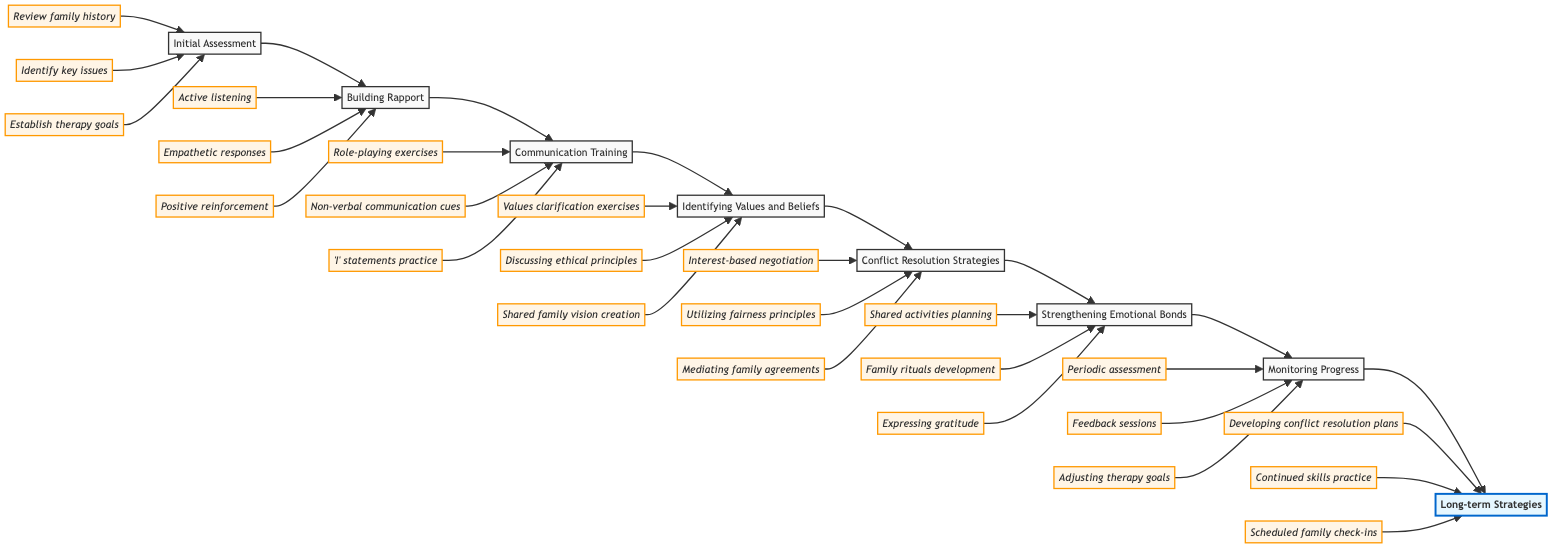What is the first step in the family therapy process? The first step in the family therapy process is depicted as the node labeled "Initial Assessment." This is the starting point of the flowchart.
Answer: Initial Assessment How many steps are included in the flowchart? By counting the nodes in the diagram, there are eight distinct steps involved in the family therapy process.
Answer: 8 What action is associated with "Building Rapport"? The actions related to "Building Rapport" include "Active listening," "Empathetic responses," and "Positive reinforcement," as indicated below this step in the diagram.
Answer: Active listening, Empathetic responses, Positive reinforcement Which step follows “Communication Training”? The flowchart shows that the step that immediately follows "Communication Training" is "Identifying Values and Beliefs." This is directly connected to "Communication Training" in the sequential layout.
Answer: Identifying Values and Beliefs What action might you take during the "Strengthening Emotional Bonds" step? Within the "Strengthening Emotional Bonds" step, actions such as "Shared activities planning" are specified. This indicates what can be done at this stage.
Answer: Shared activities planning How does the step "Identifying Values and Beliefs" relate to "Conflict Resolution Strategies"? The diagram demonstrates a direct linkage, where "Identifying Values and Beliefs" is followed by "Conflict Resolution Strategies," indicating that understanding values leads to better conflict resolution in the therapy process.
Answer: It is the next step What is the last action under "Long-term Strategies"? The final action mentioned under "Long-term Strategies" is "Scheduled family check-ins," which helps to sustain trust and communication over time.
Answer: Scheduled family check-ins Which action is part of the "Conflict Resolution Strategies"? Under "Conflict Resolution Strategies," one of the actions listed is "Utilizing fairness principles," which denotes an ethical approach to resolving conflicts within the family.
Answer: Utilizing fairness principles What are the two key components of the "Monitoring Progress" step? The key components described under "Monitoring Progress" include "Periodic assessment" and "Feedback sessions," which are essential for evaluation and adaptation of therapy practices.
Answer: Periodic assessment, Feedback sessions 